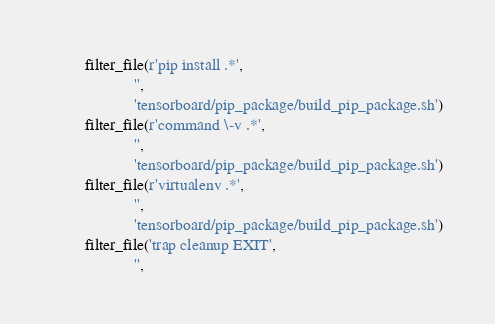Convert code to text. <code><loc_0><loc_0><loc_500><loc_500><_Python_>        filter_file(r'pip install .*',
                    '',
                    'tensorboard/pip_package/build_pip_package.sh')
        filter_file(r'command \-v .*',
                    '',
                    'tensorboard/pip_package/build_pip_package.sh')
        filter_file(r'virtualenv .*',
                    '',
                    'tensorboard/pip_package/build_pip_package.sh')
        filter_file('trap cleanup EXIT',
                    '',</code> 